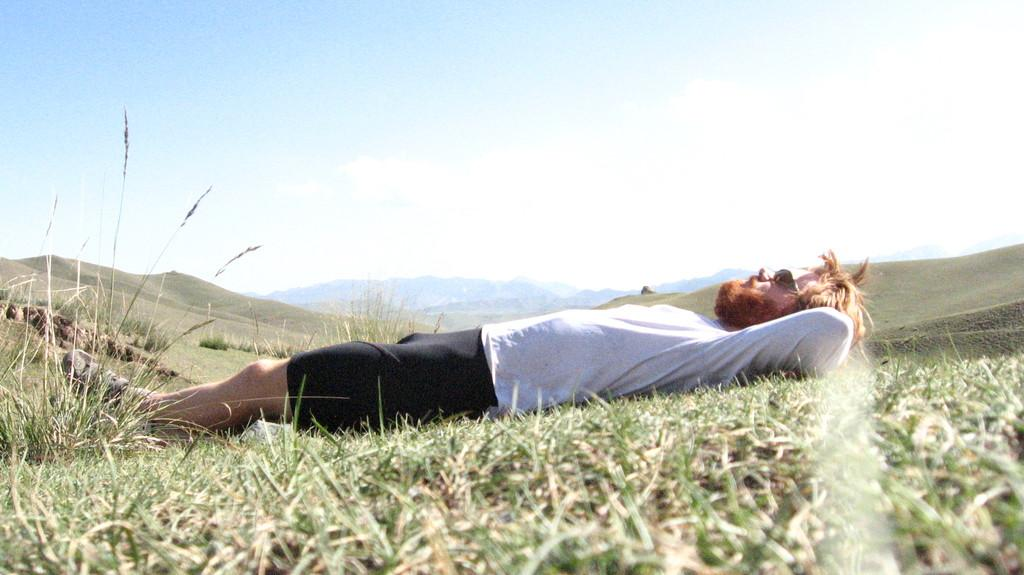Who is present in the image? There is a man in the image. What is the man doing in the image? The man is lying on the grass. What can be seen in the background of the image? Hills and the sky are visible in the background of the image. What type of calendar is the man holding in the image? There is no calendar present in the image; the man is lying on the grass with no visible objects in his hands. 